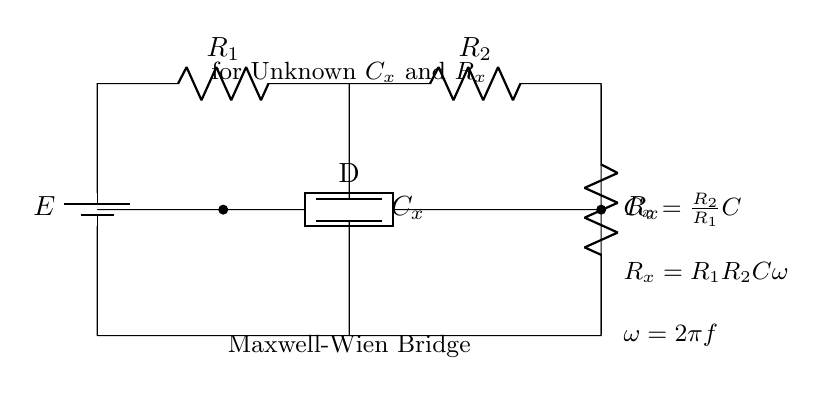What is the power source in this circuit? The power source is a battery, indicated by the symbol with the label E. It provides the necessary voltage for the circuit to function.
Answer: Battery What are the resistances present in the circuit? The resistances are R1 and R2, which are explicitly labeled in the diagram. They represent the resistors connected in the circuit.
Answer: R1, R2 What does Cx represent in the circuit? Cx represents the unknown capacitance that is being measured by the Maxwell-Wien bridge. It is the component that is in question in this configuration.
Answer: Unknown capacitance What is the relationship between Cx, R1, and R2 as shown? The relationship is stated in the equations noted in the diagram: Cx = (R2/R1)C. This means that the unknown capacitance Cx can be calculated when R1, R2, and a known capacitance C are provided.
Answer: Cx = R2/R1 * C How can R_x be calculated in the circuit? R_x can be calculated using the given formula: R_x = R1 * R2 * C * omega, where omega is the angular frequency derived from the frequency f. This reflects a deeper understanding of the circuit's workings.
Answer: R_x = R1 * R2 * C * omega Which component is responsible for phase difference measurement? The generic element labeled D represents the component that helps measure the phase difference in the Maxwell-Wien bridge. It is crucial in balancing the bridge to determine the unknown components.
Answer: Generic element D 